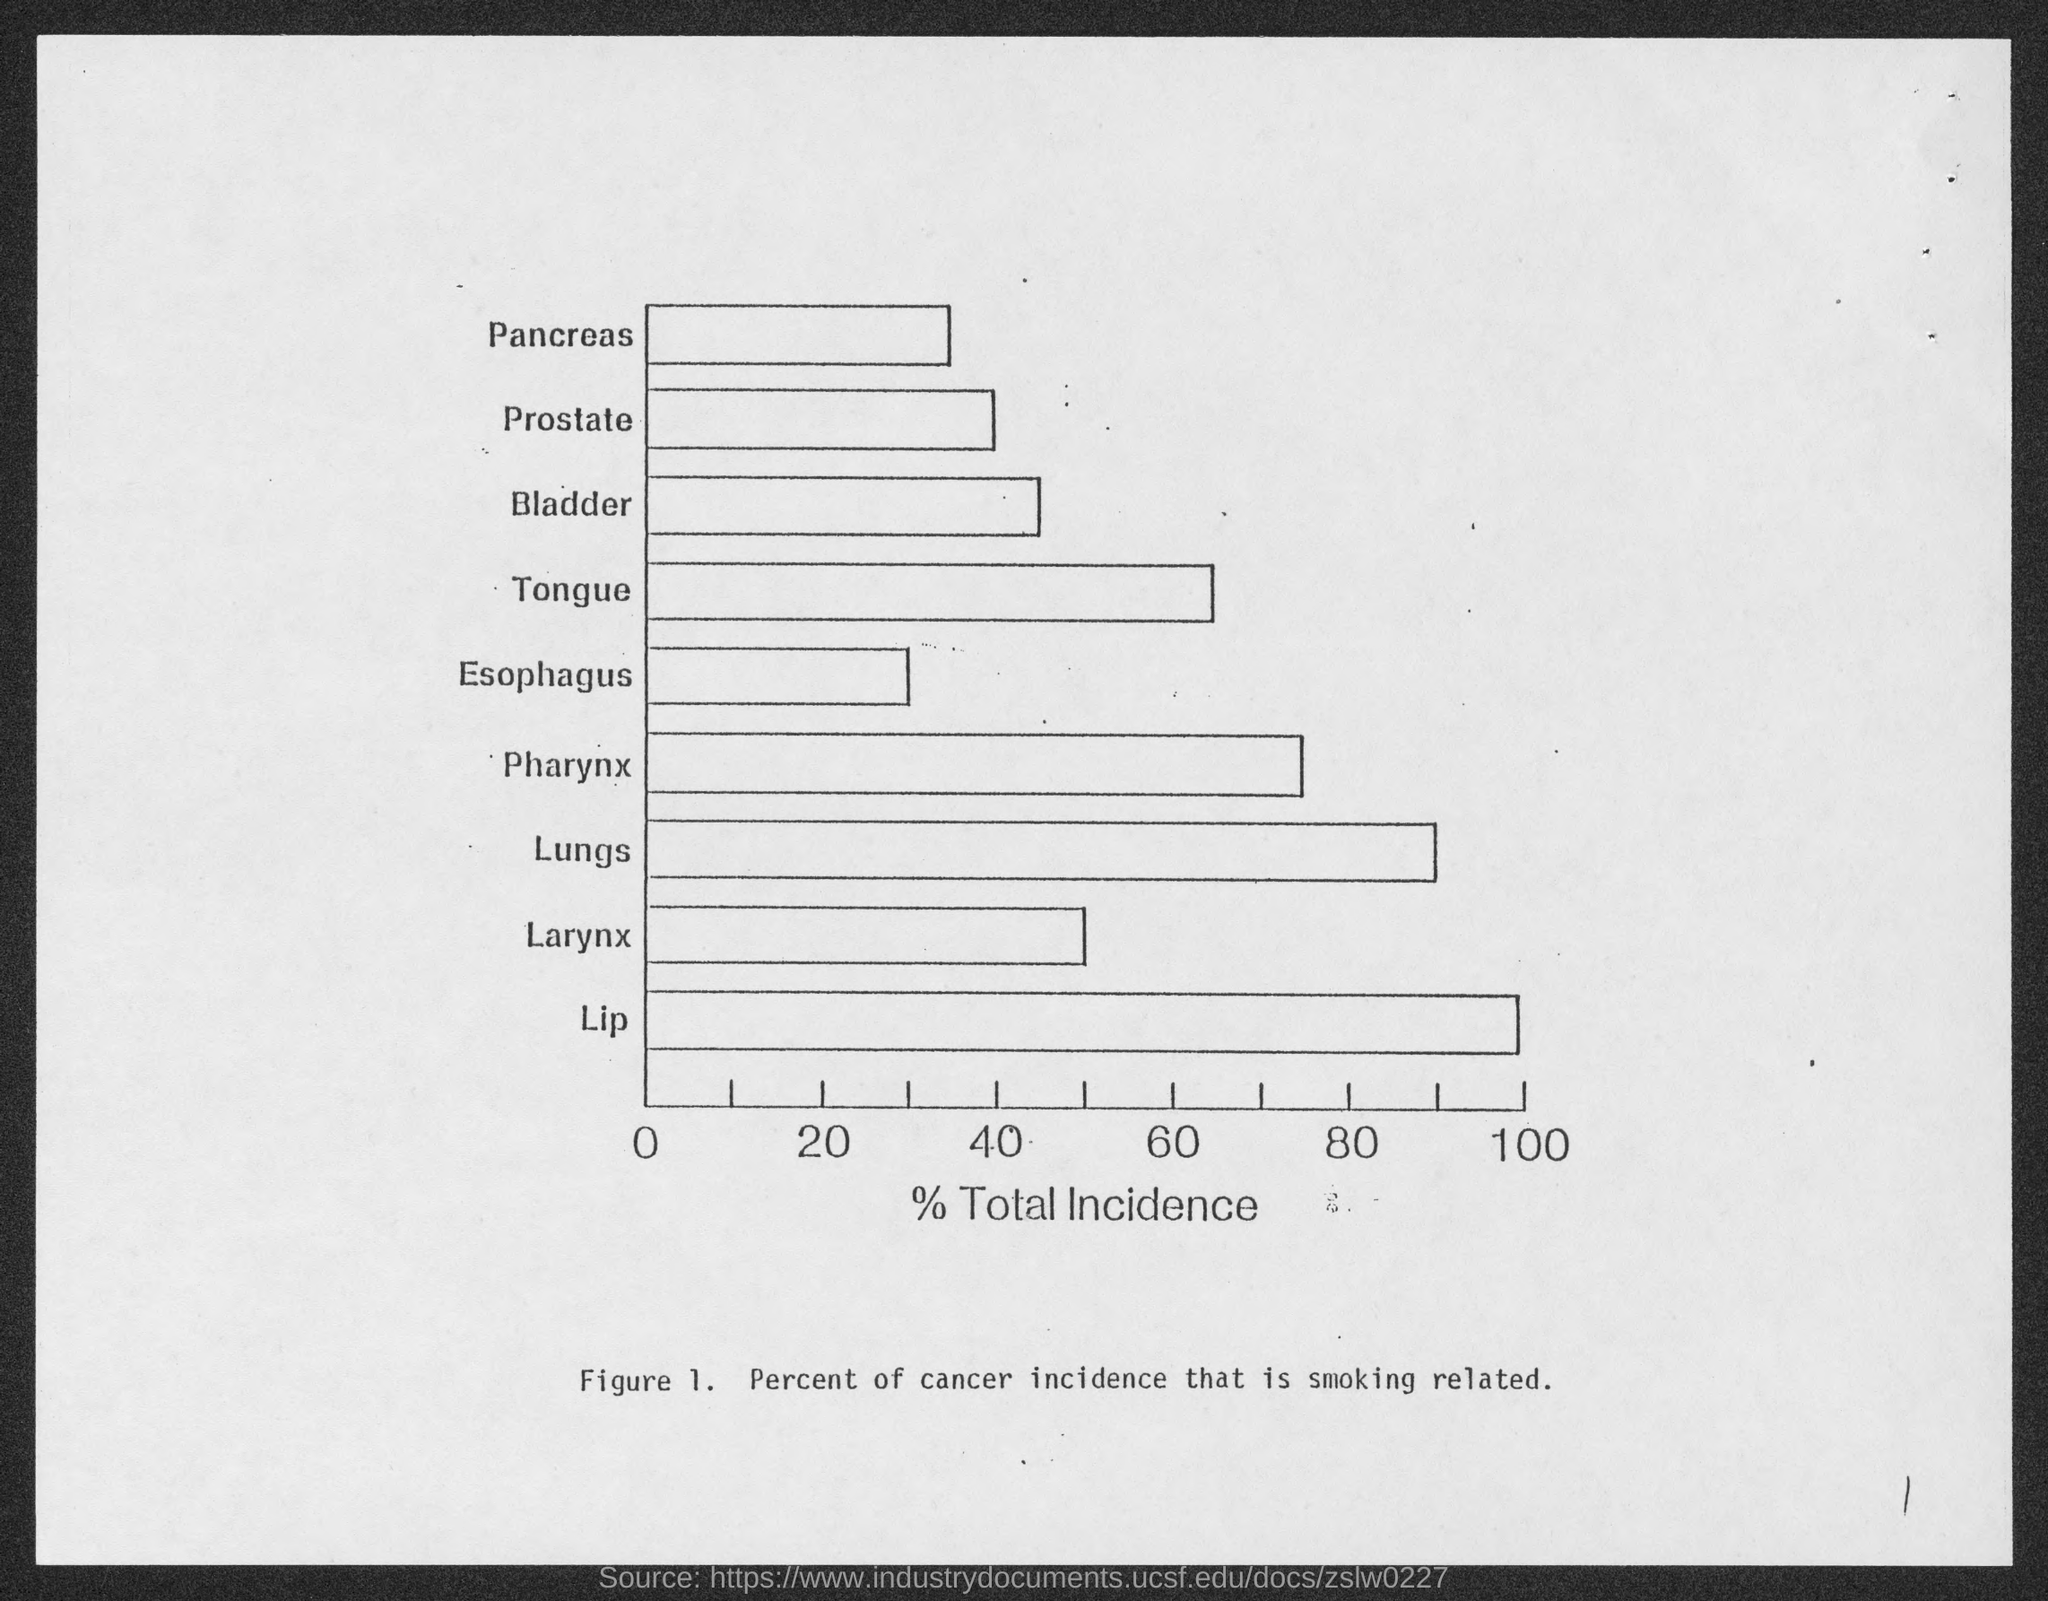What does Figure 1 represent?
Provide a succinct answer. Percent of cancer incidence that is smoking related. What does the x-axis of Figure 1. represent?
Give a very brief answer. % total incidence. 